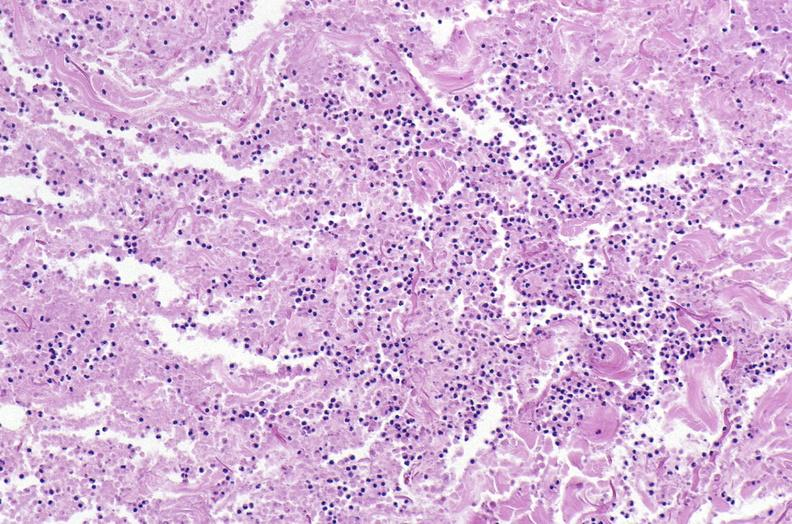does this image show panniculitis and fascitis?
Answer the question using a single word or phrase. Yes 